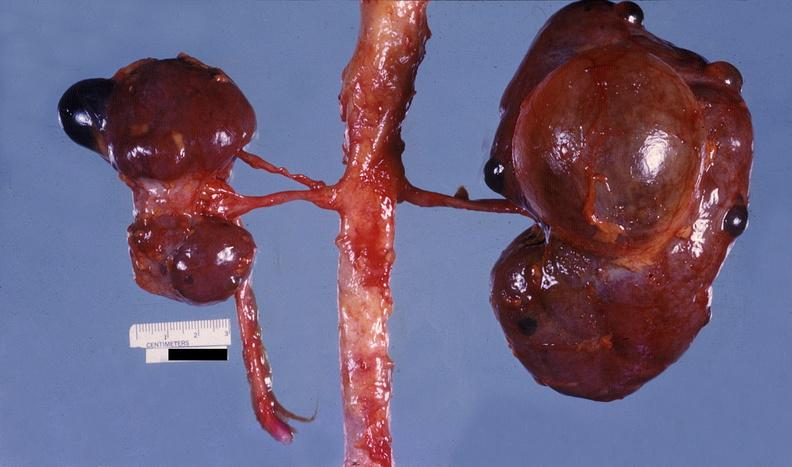does cranial artery show kidney, pyelonephritis?
Answer the question using a single word or phrase. No 